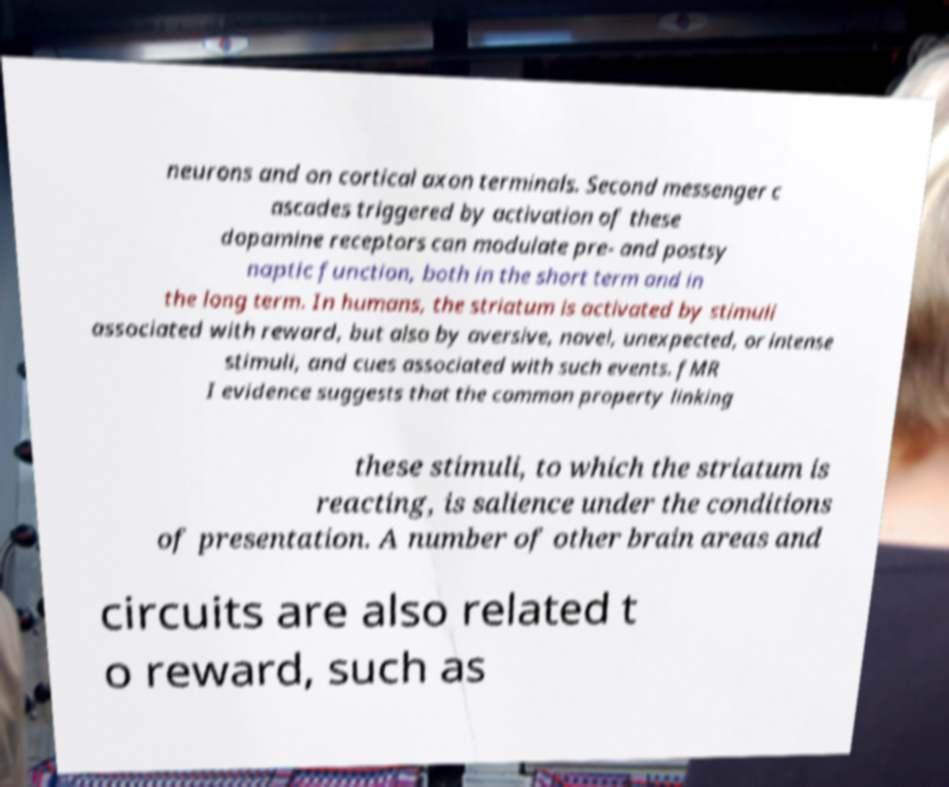Please identify and transcribe the text found in this image. neurons and on cortical axon terminals. Second messenger c ascades triggered by activation of these dopamine receptors can modulate pre- and postsy naptic function, both in the short term and in the long term. In humans, the striatum is activated by stimuli associated with reward, but also by aversive, novel, unexpected, or intense stimuli, and cues associated with such events. fMR I evidence suggests that the common property linking these stimuli, to which the striatum is reacting, is salience under the conditions of presentation. A number of other brain areas and circuits are also related t o reward, such as 